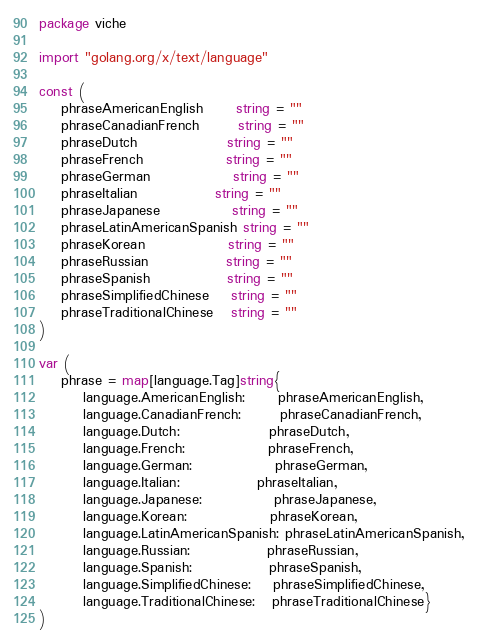<code> <loc_0><loc_0><loc_500><loc_500><_Go_>package viche

import "golang.org/x/text/language"

const (
	phraseAmericanEnglish      string = ""
	phraseCanadianFrench       string = ""
	phraseDutch                string = ""
	phraseFrench               string = ""
	phraseGerman               string = ""
	phraseItalian              string = ""
	phraseJapanese             string = ""
	phraseLatinAmericanSpanish string = ""
	phraseKorean               string = ""
	phraseRussian              string = ""
	phraseSpanish              string = ""
	phraseSimplifiedChinese    string = ""
	phraseTraditionalChinese   string = ""
)

var (
	phrase = map[language.Tag]string{
		language.AmericanEnglish:      phraseAmericanEnglish,
		language.CanadianFrench:       phraseCanadianFrench,
		language.Dutch:                phraseDutch,
		language.French:               phraseFrench,
		language.German:               phraseGerman,
		language.Italian:              phraseItalian,
		language.Japanese:             phraseJapanese,
		language.Korean:               phraseKorean,
		language.LatinAmericanSpanish: phraseLatinAmericanSpanish,
		language.Russian:              phraseRussian,
		language.Spanish:              phraseSpanish,
		language.SimplifiedChinese:    phraseSimplifiedChinese,
		language.TraditionalChinese:   phraseTraditionalChinese}
)
</code> 